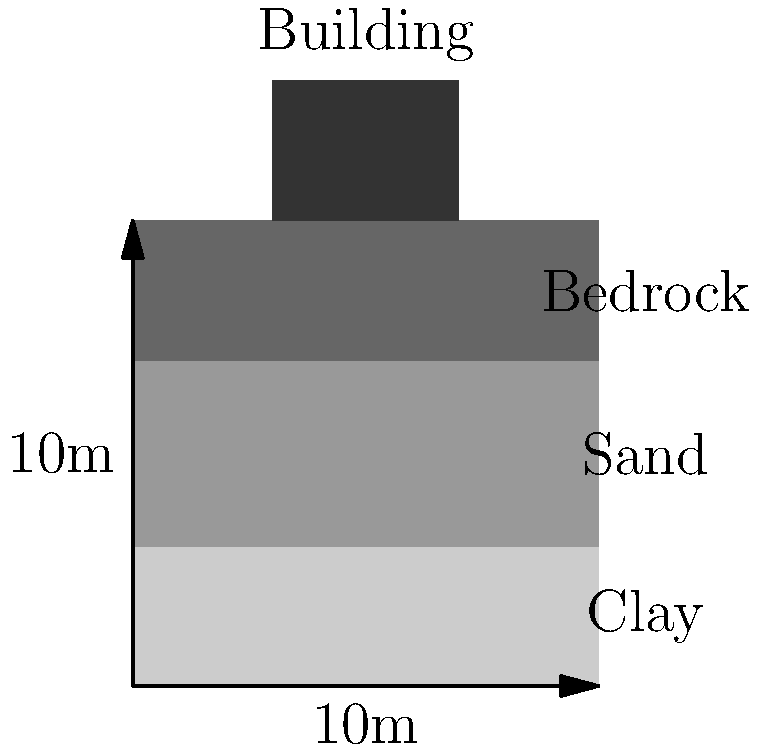A 4-story building with a total weight of 8000 kN is constructed on a square foundation (4m x 4m) resting on layered soil as shown in the figure. The soil profile consists of a 3m thick clay layer (elastic modulus $E_1 = 20$ MPa) over a 4m thick sand layer (elastic modulus $E_2 = 50$ MPa), both underlain by bedrock. Using the elastic theory method, estimate the total settlement of the building foundation in millimeters (mm). Assume a Poisson's ratio of 0.3 for both soil layers and that the stress distribution follows a 2:1 slope. To calculate the settlement, we'll use the elastic theory method and follow these steps:

1) Calculate the stress increase at the midpoint of each layer:
   - Foundation pressure: $p = \frac{8000 \text{ kN}}{4\text{ m} \times 4\text{ m}} = 500 \text{ kPa}$
   - For clay layer (depth = 1.5m): $\Delta \sigma_1 = \frac{500}{(4 + 2 \times 1.5)^2} \times 4^2 = 282.84 \text{ kPa}$
   - For sand layer (depth = 5m): $\Delta \sigma_2 = \frac{500}{(4 + 2 \times 5)^2} \times 4^2 = 69.44 \text{ kPa}$

2) Calculate the settlement for each layer using the formula:
   $S = \frac{\Delta \sigma H (1 - \nu^2)}{E}$

   For clay layer:
   $S_1 = \frac{282.84 \times 3000 \times (1 - 0.3^2)}{20 \times 10^6} = 36.97 \text{ mm}$

   For sand layer:
   $S_2 = \frac{69.44 \times 4000 \times (1 - 0.3^2)}{50 \times 10^6} = 4.84 \text{ mm}$

3) Calculate the total settlement:
   $S_{\text{total}} = S_1 + S_2 = 36.97 + 4.84 = 41.81 \text{ mm}$

Therefore, the estimated total settlement of the building foundation is approximately 41.81 mm.
Answer: 41.81 mm 